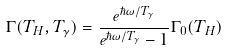Convert formula to latex. <formula><loc_0><loc_0><loc_500><loc_500>\Gamma ( T _ { H } , T _ { \gamma } ) = \frac { e ^ { \hbar { \omega } / T _ { \gamma } } } { e ^ { \hbar { \omega } / T _ { \gamma } } - 1 } \Gamma _ { 0 } ( T _ { H } )</formula> 